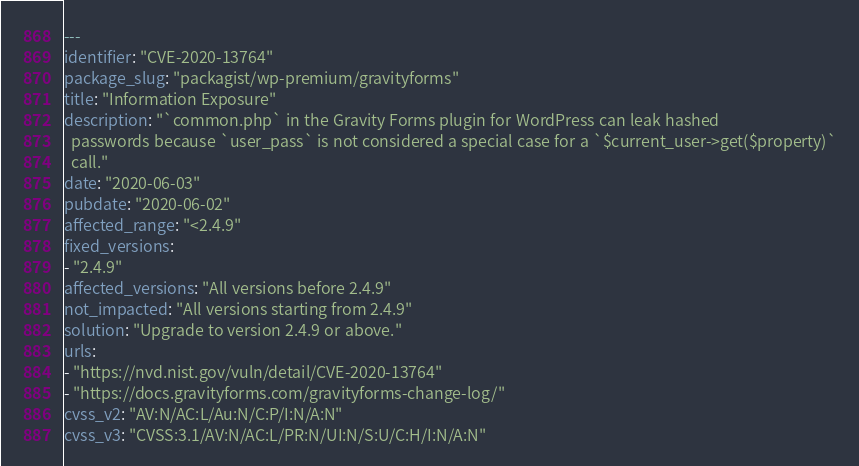Convert code to text. <code><loc_0><loc_0><loc_500><loc_500><_YAML_>---
identifier: "CVE-2020-13764"
package_slug: "packagist/wp-premium/gravityforms"
title: "Information Exposure"
description: "`common.php` in the Gravity Forms plugin for WordPress can leak hashed
  passwords because `user_pass` is not considered a special case for a `$current_user->get($property)`
  call."
date: "2020-06-03"
pubdate: "2020-06-02"
affected_range: "<2.4.9"
fixed_versions:
- "2.4.9"
affected_versions: "All versions before 2.4.9"
not_impacted: "All versions starting from 2.4.9"
solution: "Upgrade to version 2.4.9 or above."
urls:
- "https://nvd.nist.gov/vuln/detail/CVE-2020-13764"
- "https://docs.gravityforms.com/gravityforms-change-log/"
cvss_v2: "AV:N/AC:L/Au:N/C:P/I:N/A:N"
cvss_v3: "CVSS:3.1/AV:N/AC:L/PR:N/UI:N/S:U/C:H/I:N/A:N"</code> 